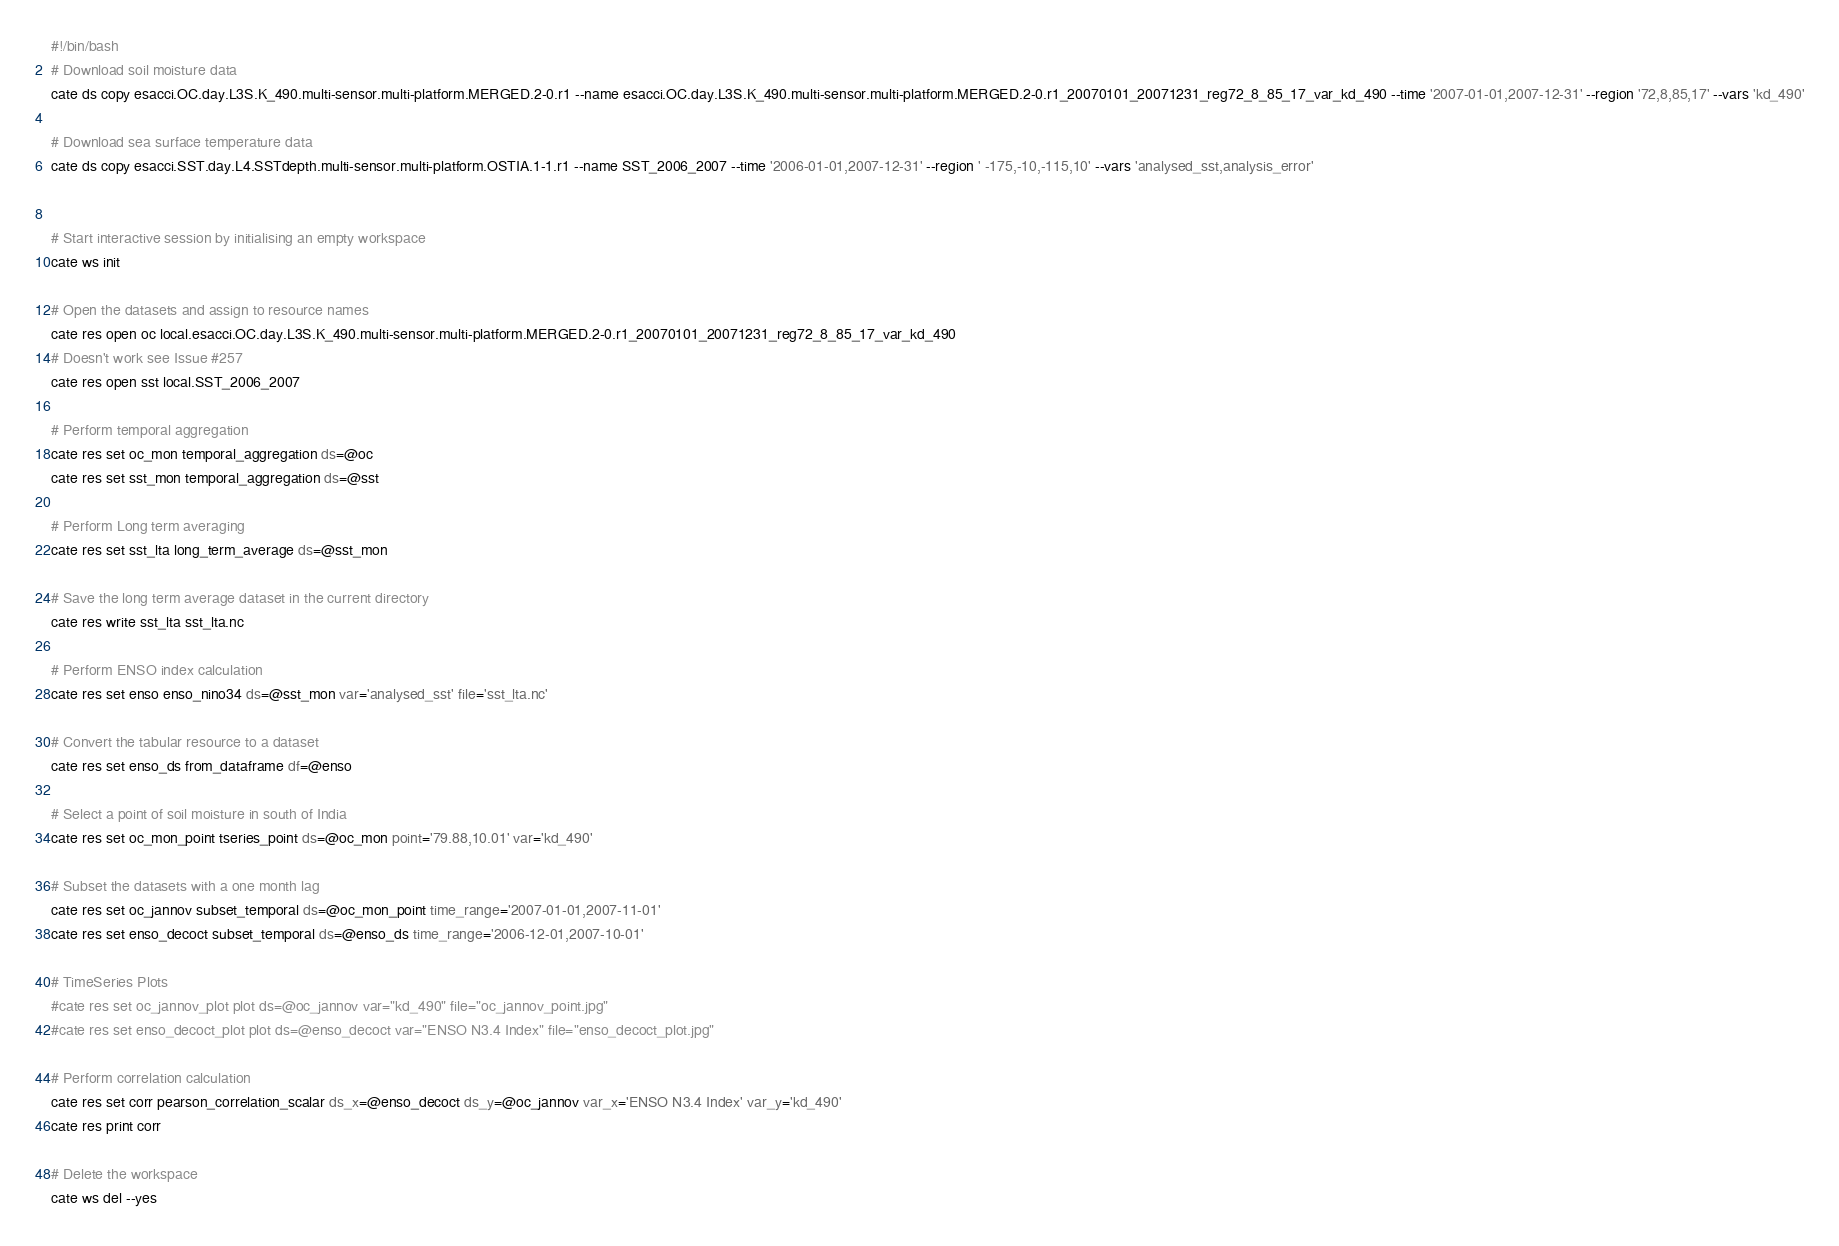<code> <loc_0><loc_0><loc_500><loc_500><_Bash_>#!/bin/bash
# Download soil moisture data
cate ds copy esacci.OC.day.L3S.K_490.multi-sensor.multi-platform.MERGED.2-0.r1 --name esacci.OC.day.L3S.K_490.multi-sensor.multi-platform.MERGED.2-0.r1_20070101_20071231_reg72_8_85_17_var_kd_490 --time '2007-01-01,2007-12-31' --region '72,8,85,17' --vars 'kd_490'

# Download sea surface temperature data
cate ds copy esacci.SST.day.L4.SSTdepth.multi-sensor.multi-platform.OSTIA.1-1.r1 --name SST_2006_2007 --time '2006-01-01,2007-12-31' --region ' -175,-10,-115,10' --vars 'analysed_sst,analysis_error'


# Start interactive session by initialising an empty workspace
cate ws init

# Open the datasets and assign to resource names
cate res open oc local.esacci.OC.day.L3S.K_490.multi-sensor.multi-platform.MERGED.2-0.r1_20070101_20071231_reg72_8_85_17_var_kd_490
# Doesn't work see Issue #257
cate res open sst local.SST_2006_2007

# Perform temporal aggregation
cate res set oc_mon temporal_aggregation ds=@oc
cate res set sst_mon temporal_aggregation ds=@sst

# Perform Long term averaging
cate res set sst_lta long_term_average ds=@sst_mon

# Save the long term average dataset in the current directory
cate res write sst_lta sst_lta.nc

# Perform ENSO index calculation
cate res set enso enso_nino34 ds=@sst_mon var='analysed_sst' file='sst_lta.nc'

# Convert the tabular resource to a dataset
cate res set enso_ds from_dataframe df=@enso

# Select a point of soil moisture in south of India
cate res set oc_mon_point tseries_point ds=@oc_mon point='79.88,10.01' var='kd_490'

# Subset the datasets with a one month lag
cate res set oc_jannov subset_temporal ds=@oc_mon_point time_range='2007-01-01,2007-11-01'
cate res set enso_decoct subset_temporal ds=@enso_ds time_range='2006-12-01,2007-10-01'

# TimeSeries Plots
#cate res set oc_jannov_plot plot ds=@oc_jannov var="kd_490" file="oc_jannov_point.jpg"
#cate res set enso_decoct_plot plot ds=@enso_decoct var="ENSO N3.4 Index" file="enso_decoct_plot.jpg"

# Perform correlation calculation
cate res set corr pearson_correlation_scalar ds_x=@enso_decoct ds_y=@oc_jannov var_x='ENSO N3.4 Index' var_y='kd_490'
cate res print corr

# Delete the workspace
cate ws del --yes
</code> 